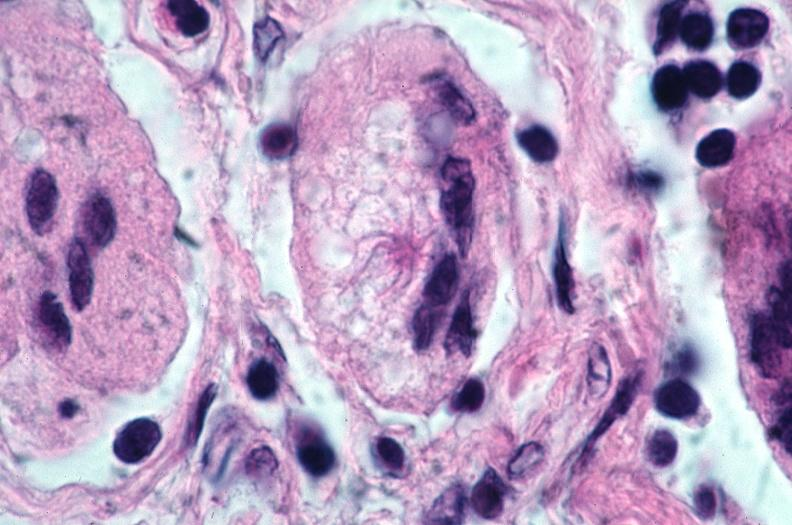where is this?
Answer the question using a single word or phrase. Lung 